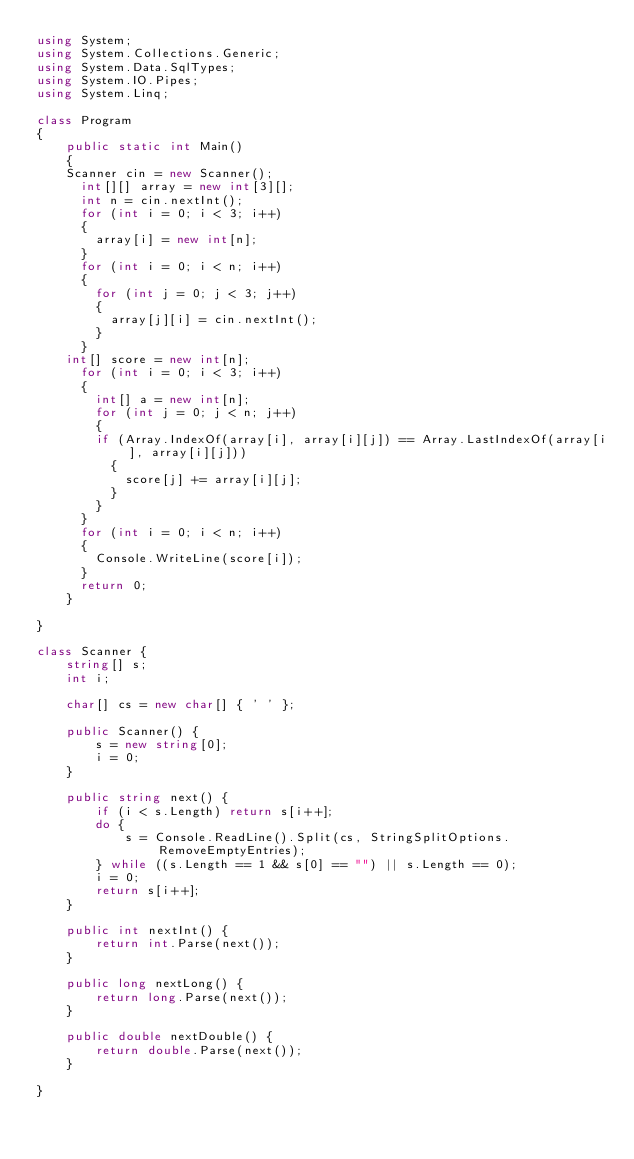<code> <loc_0><loc_0><loc_500><loc_500><_C#_>using System;
using System.Collections.Generic;
using System.Data.SqlTypes;
using System.IO.Pipes;
using System.Linq;

class Program
{ 
	public static int Main()
	{
    Scanner cin = new Scanner();
	  int[][] array = new int[3][];
	  int n = cin.nextInt();
	  for (int i = 0; i < 3; i++)
	  {
	    array[i] = new int[n];
	  }
	  for (int i = 0; i < n; i++)
	  {
	    for (int j = 0; j < 3; j++)
	    {
	      array[j][i] = cin.nextInt();
	    }
	  }
    int[] score = new int[n];
	  for (int i = 0; i < 3; i++)
	  {
	    int[] a = new int[n];
	    for (int j = 0; j < n; j++)
	    {
        if (Array.IndexOf(array[i], array[i][j]) == Array.LastIndexOf(array[i], array[i][j]))
	      {
	        score[j] += array[i][j];
	      }
	    }
	  }
	  for (int i = 0; i < n; i++)
	  {
	    Console.WriteLine(score[i]);
	  }
	  return 0;
	}

}

class Scanner {
	string[] s;
	int i;

	char[] cs = new char[] { ' ' };

	public Scanner() {
		s = new string[0];
		i = 0;
	}

	public string next() {
		if (i < s.Length) return s[i++];
		do {
			s = Console.ReadLine().Split(cs, StringSplitOptions.RemoveEmptyEntries);
		} while ((s.Length == 1 && s[0] == "") || s.Length == 0);
		i = 0;
		return s[i++];
	}

	public int nextInt() {
		return int.Parse(next());
	}

	public long nextLong() {
		return long.Parse(next());
	}

	public double nextDouble() {
		return double.Parse(next());
	}

}</code> 